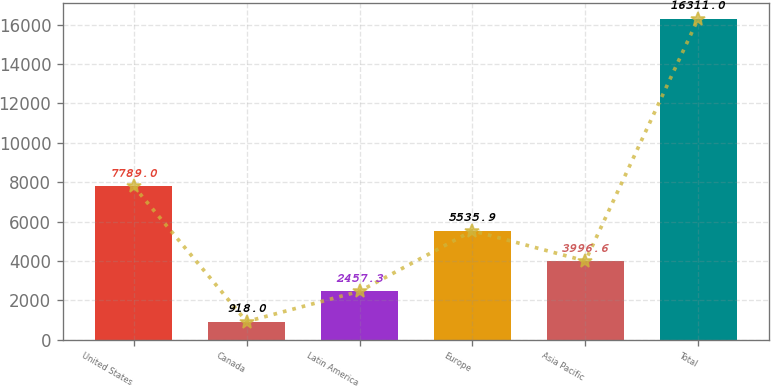<chart> <loc_0><loc_0><loc_500><loc_500><bar_chart><fcel>United States<fcel>Canada<fcel>Latin America<fcel>Europe<fcel>Asia Pacific<fcel>Total<nl><fcel>7789<fcel>918<fcel>2457.3<fcel>5535.9<fcel>3996.6<fcel>16311<nl></chart> 